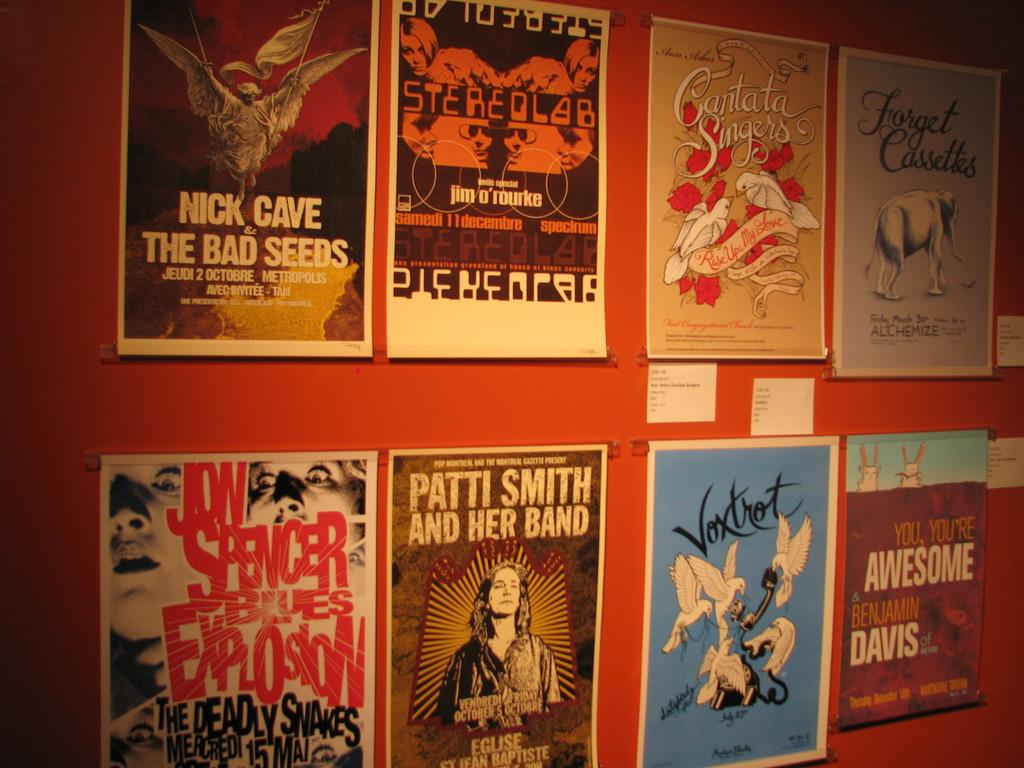<image>
Describe the image concisely. The top left poster is for the play The Bad Seeds 